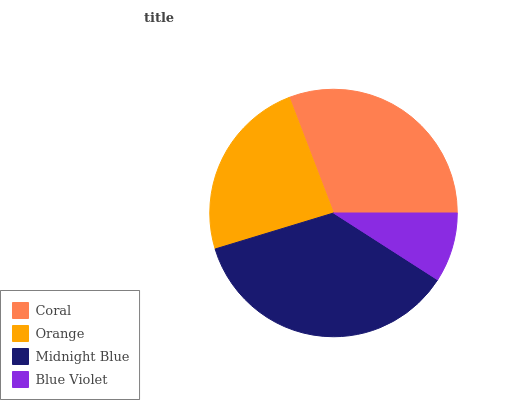Is Blue Violet the minimum?
Answer yes or no. Yes. Is Midnight Blue the maximum?
Answer yes or no. Yes. Is Orange the minimum?
Answer yes or no. No. Is Orange the maximum?
Answer yes or no. No. Is Coral greater than Orange?
Answer yes or no. Yes. Is Orange less than Coral?
Answer yes or no. Yes. Is Orange greater than Coral?
Answer yes or no. No. Is Coral less than Orange?
Answer yes or no. No. Is Coral the high median?
Answer yes or no. Yes. Is Orange the low median?
Answer yes or no. Yes. Is Blue Violet the high median?
Answer yes or no. No. Is Midnight Blue the low median?
Answer yes or no. No. 